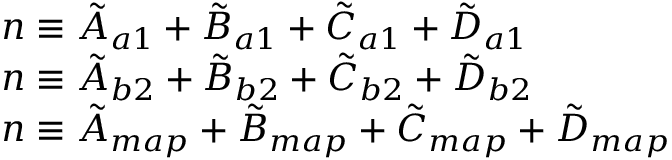Convert formula to latex. <formula><loc_0><loc_0><loc_500><loc_500>\begin{array} { l } { n \equiv \tilde { A } _ { a 1 } + \tilde { B } _ { a 1 } + \tilde { C } _ { a 1 } + \tilde { D } _ { a 1 } } \\ { n \equiv \tilde { A } _ { b 2 } + \tilde { B } _ { b 2 } + \tilde { C } _ { b 2 } + \tilde { D } _ { b 2 } } \\ { n \equiv \tilde { A } _ { m a p } + \tilde { B } _ { m a p } + \tilde { C } _ { m a p } + \tilde { D } _ { m a p } } \end{array}</formula> 